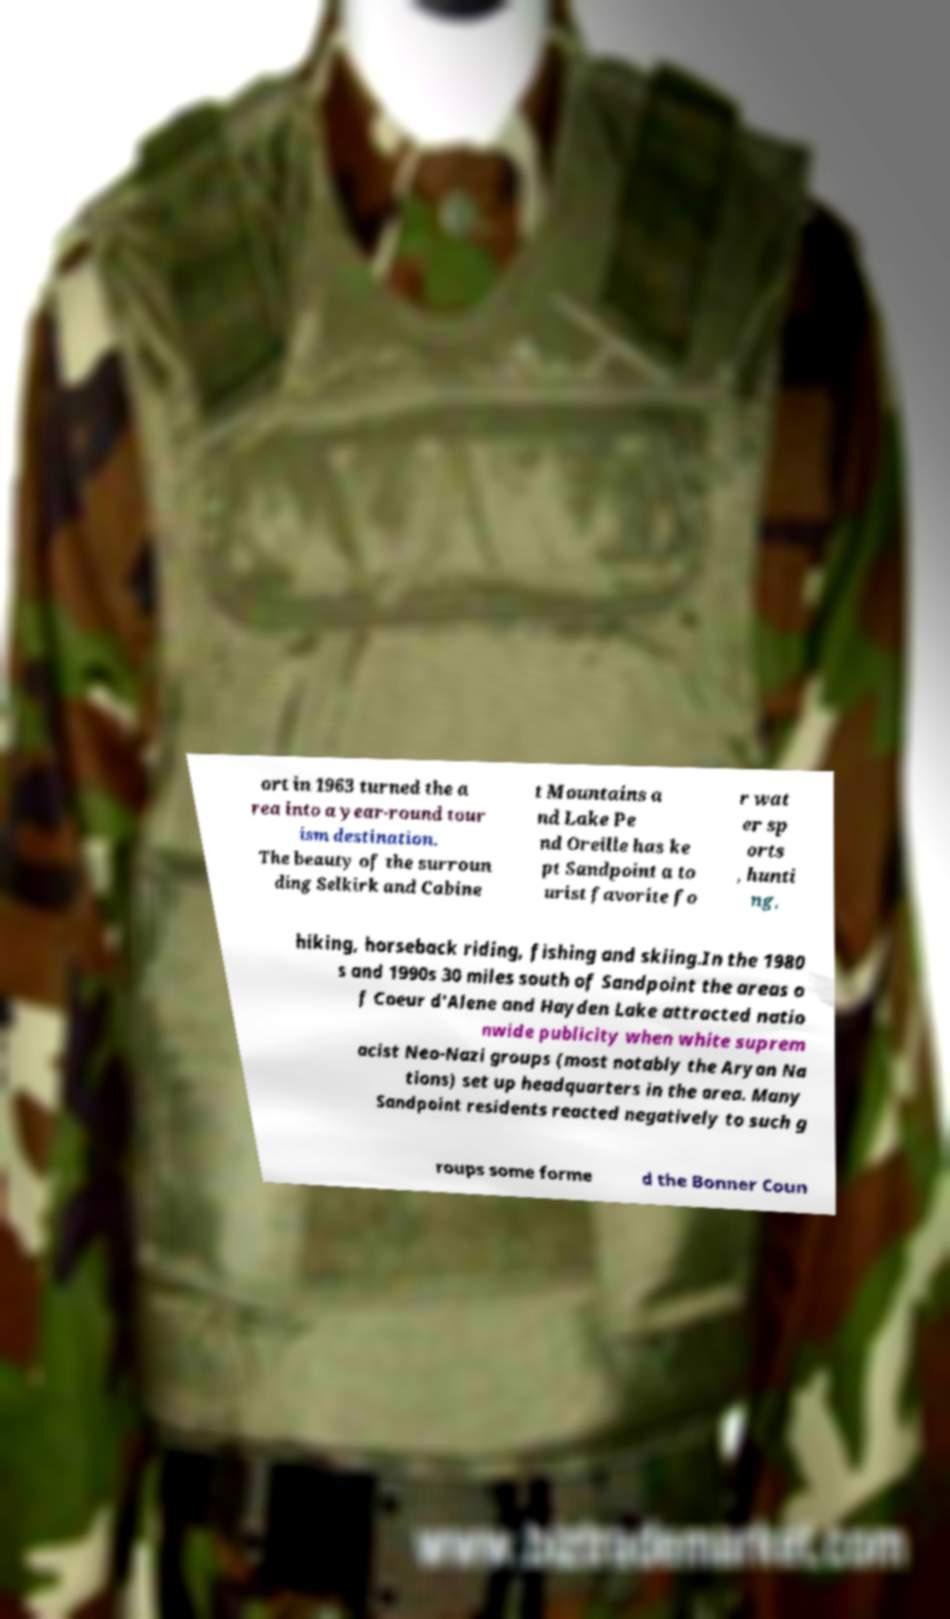Can you accurately transcribe the text from the provided image for me? ort in 1963 turned the a rea into a year-round tour ism destination. The beauty of the surroun ding Selkirk and Cabine t Mountains a nd Lake Pe nd Oreille has ke pt Sandpoint a to urist favorite fo r wat er sp orts , hunti ng, hiking, horseback riding, fishing and skiing.In the 1980 s and 1990s 30 miles south of Sandpoint the areas o f Coeur d'Alene and Hayden Lake attracted natio nwide publicity when white suprem acist Neo-Nazi groups (most notably the Aryan Na tions) set up headquarters in the area. Many Sandpoint residents reacted negatively to such g roups some forme d the Bonner Coun 